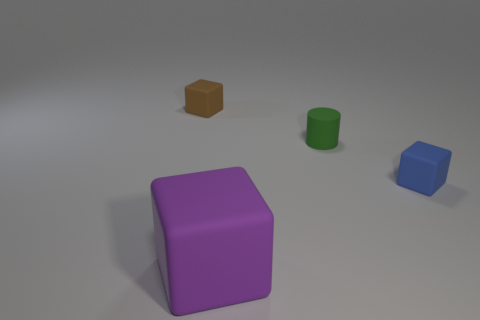Add 1 tiny blue matte things. How many objects exist? 5 Subtract all blue matte cubes. How many cubes are left? 2 Subtract all cylinders. How many objects are left? 3 Subtract all cyan cylinders. Subtract all purple spheres. How many cylinders are left? 1 Subtract all yellow balls. How many blue blocks are left? 1 Subtract all metal spheres. Subtract all small blue blocks. How many objects are left? 3 Add 1 tiny blue cubes. How many tiny blue cubes are left? 2 Add 3 blocks. How many blocks exist? 6 Subtract 0 purple spheres. How many objects are left? 4 